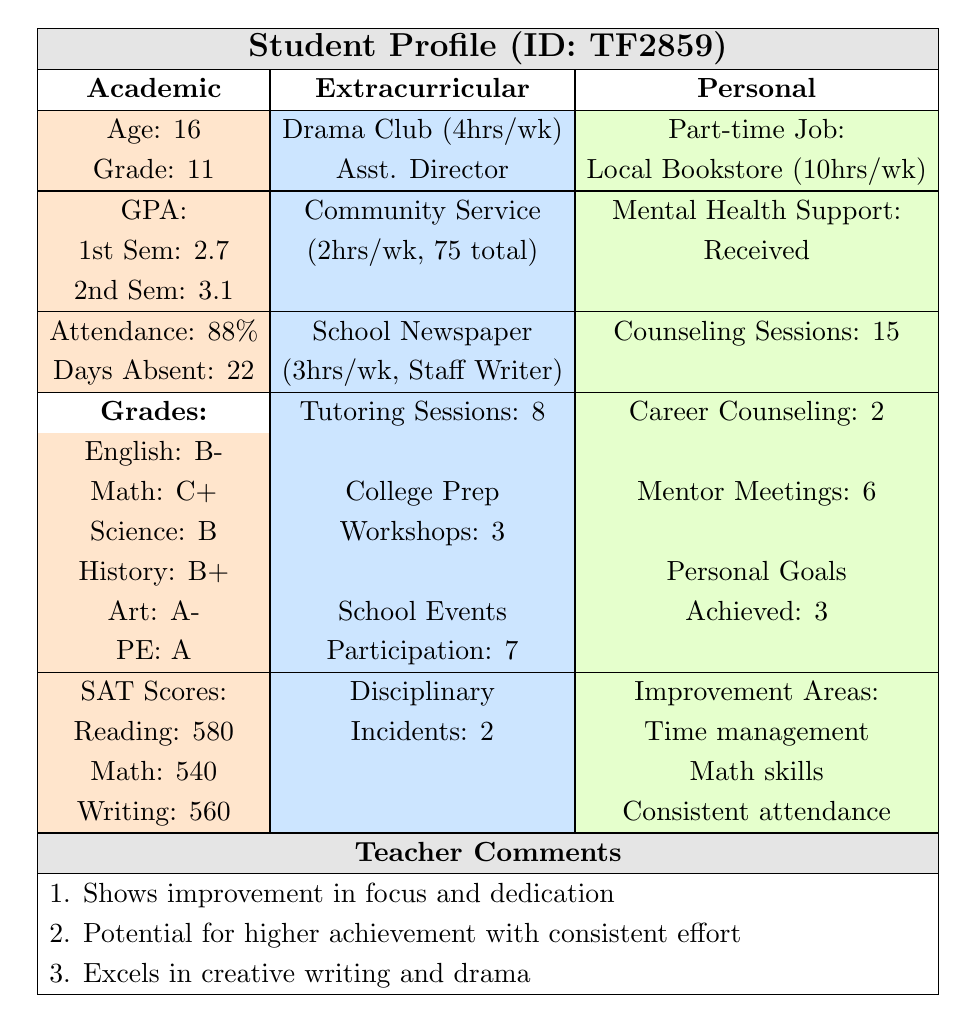What was the student's GPA in the first semester? The student's GPA in the first semester is provided directly in the table under the academic section. It reads 2.7.
Answer: 2.7 How many total hours did the student spend on community service? The table indicates the student dedicated 2 hours per week to community service and a total of 75 hours for the entire year. This is already presented as a total, so no calculations are needed.
Answer: 75 hours Did the student attend more mentoring meetings or tutoring sessions? The table lists 6 mentor meetings and 8 tutoring sessions. Comparing these two numbers, tutoring sessions (8) are greater than mentor meetings (6).
Answer: No, the student attended more tutoring sessions What is the average GPA of the student for both semesters? To find the average GPA, add the GPAs from both semesters (2.7 + 3.1 = 5.8) and divide by 2, resulting in an average of 5.8/2 = 2.9.
Answer: 2.9 How many extracurricular activities did the student participate in? The student's participation in extracurricular activities is broken down into three specific activities listed in the table: Drama Club, Community Service, and School Newspaper. Counting these gives a total of 3 activities.
Answer: 3 activities What percentage of classes did the student attend? The attendance rate provided in the table is 88%, which can be interpreted as the percentage of classes attended by the student.
Answer: 88% Did the student receive any mental health support? The table states that the student received mental health support, which indicates a "yes" response to this question.
Answer: Yes What improvement areas does the student need to focus on? The table lists three improvement areas: Time management, Math skills, and Consistent attendance. These areas need to be worked on based on the data.
Answer: Time management, Math skills, Consistent attendance What is the total number of disciplinary incidents reported? The table clearly states that the student had 2 disciplinary incidents. This value can be directly retrieved from the disciplinary section.
Answer: 2 incidents What is the student's strongest subject based on grades? By comparing the grades listed, the highest grade is an A- in Art, making it the student's strongest subject.
Answer: Art 